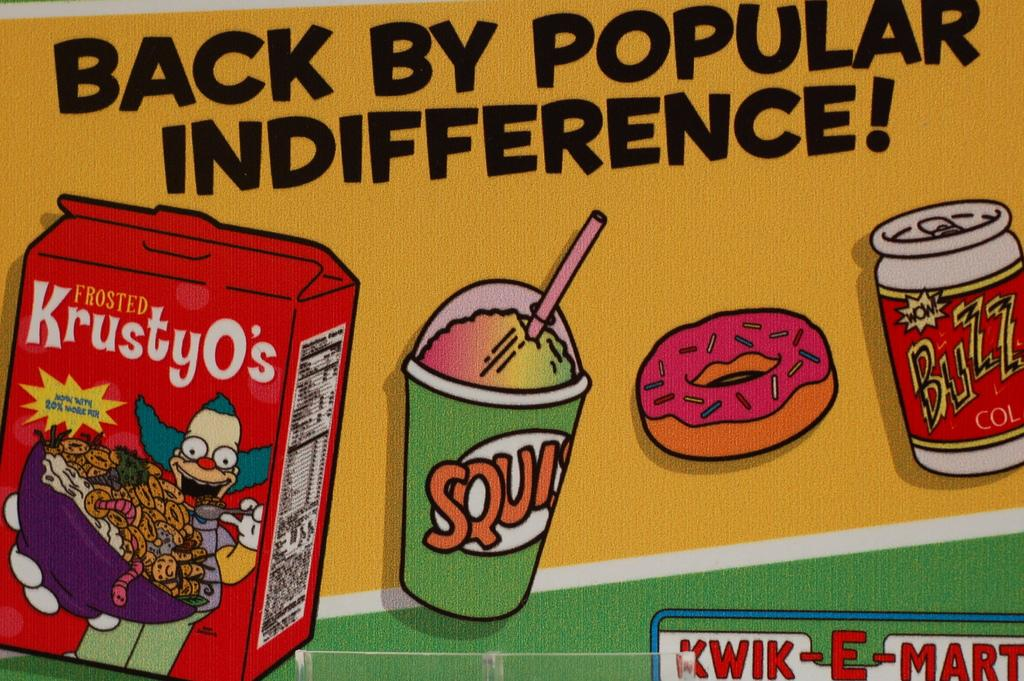Provide a one-sentence caption for the provided image. A Kwik-E-Mart ad showing KrustyO's and a drink and a donut. 